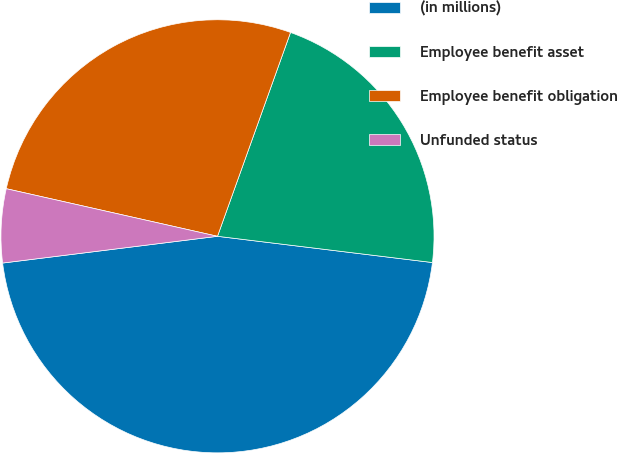Convert chart. <chart><loc_0><loc_0><loc_500><loc_500><pie_chart><fcel>(in millions)<fcel>Employee benefit asset<fcel>Employee benefit obligation<fcel>Unfunded status<nl><fcel>46.1%<fcel>21.46%<fcel>26.95%<fcel>5.5%<nl></chart> 